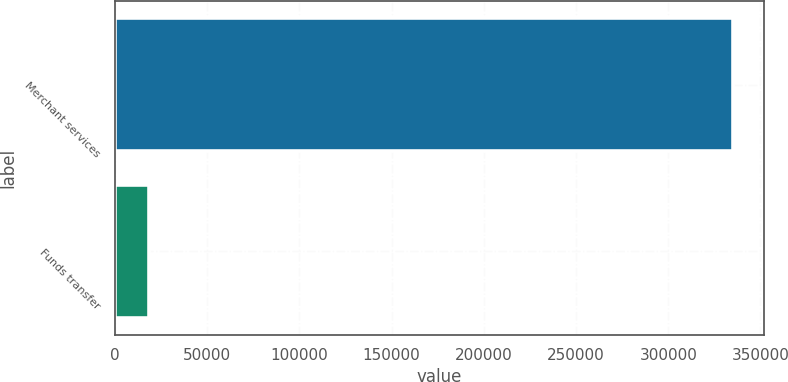Convert chart to OTSL. <chart><loc_0><loc_0><loc_500><loc_500><bar_chart><fcel>Merchant services<fcel>Funds transfer<nl><fcel>334979<fcel>18216<nl></chart> 